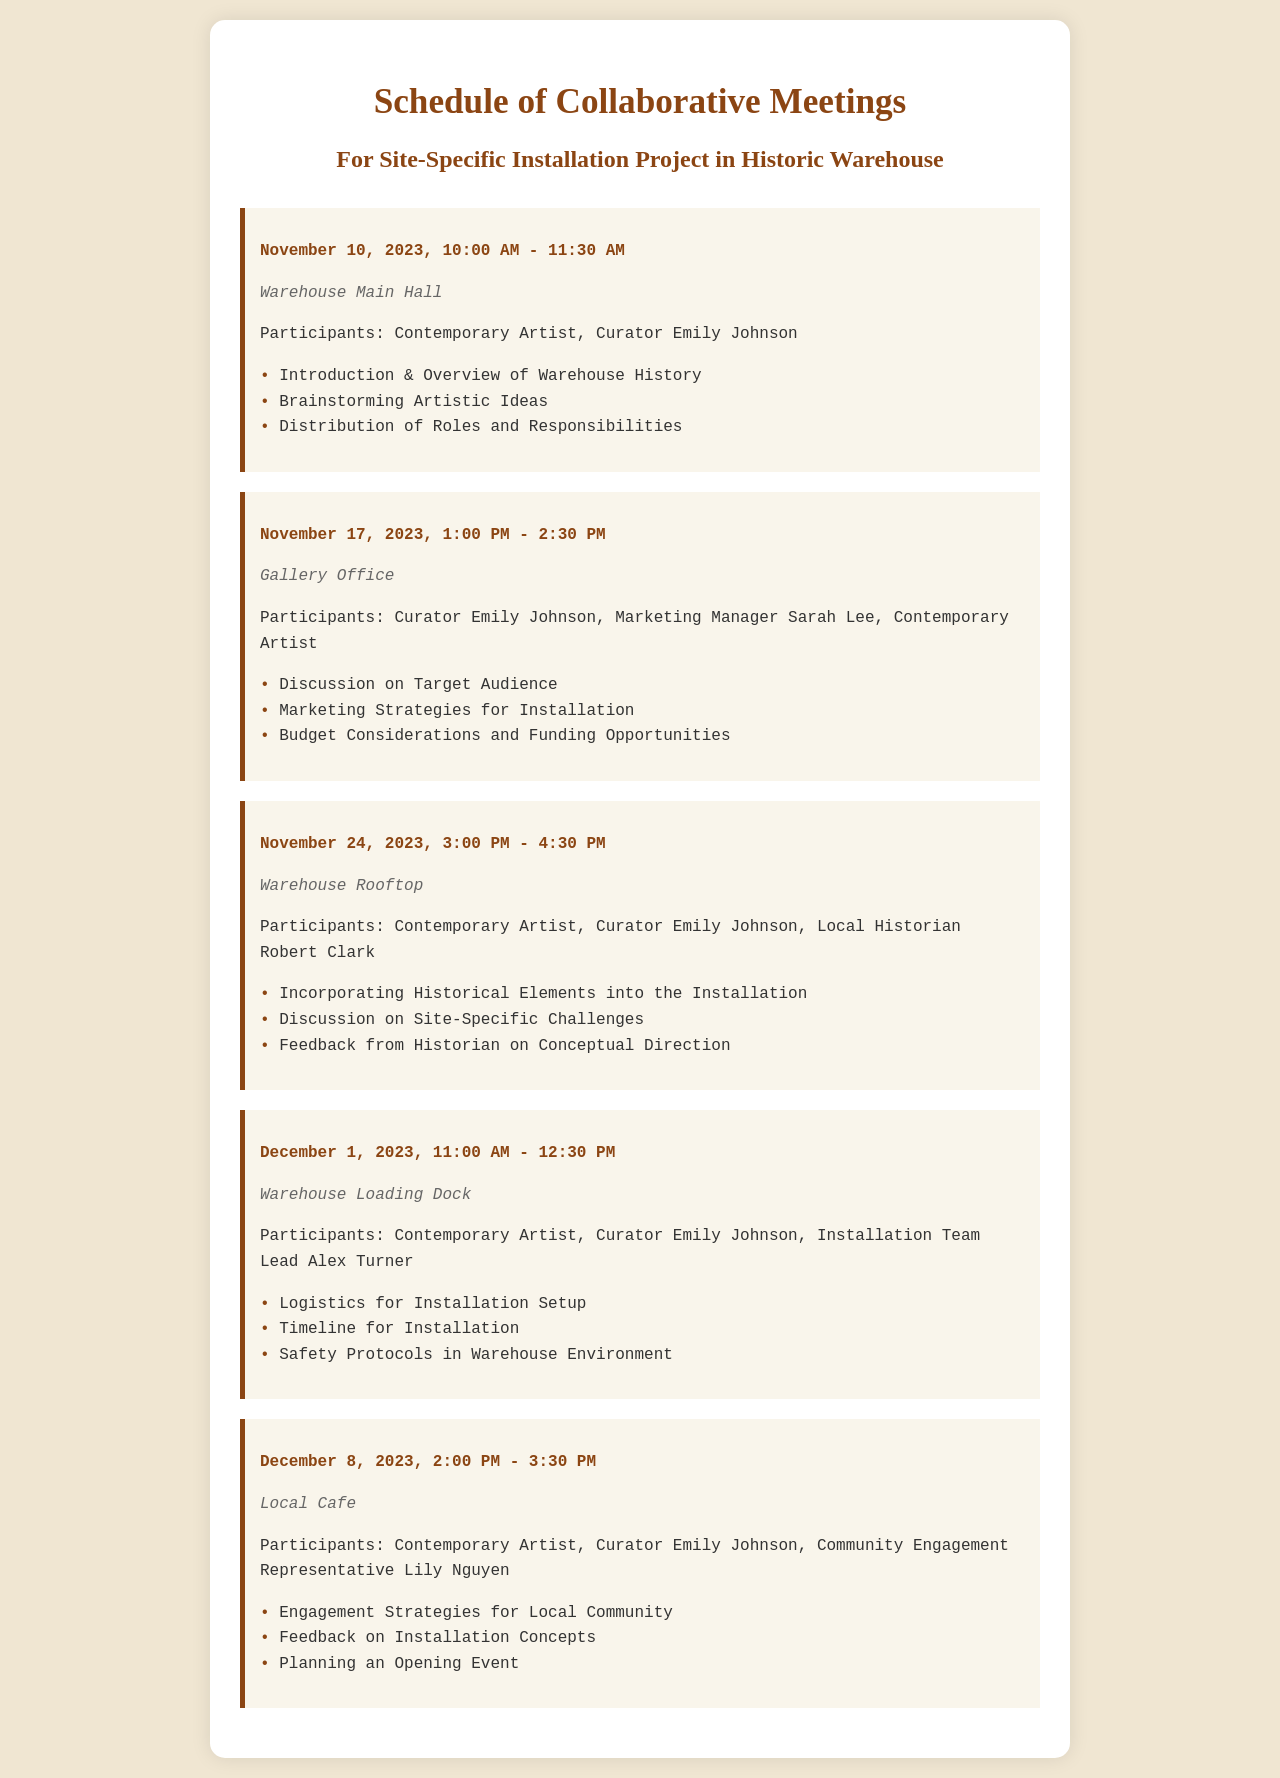What is the date and time of the first meeting? The first meeting is scheduled for November 10, 2023, at 10:00 AM.
Answer: November 10, 2023, 10:00 AM Who is participating in the second meeting? The second meeting involves the Curator, the Marketing Manager, and the Contemporary Artist.
Answer: Curator Emily Johnson, Marketing Manager Sarah Lee, Contemporary Artist Where is the fourth meeting held? The location of the fourth meeting is specified in the document.
Answer: Warehouse Loading Dock What is one agenda item for the meeting on November 24? The agenda for the November 24 meeting includes discussion on historical elements in the installation among others.
Answer: Incorporating Historical Elements into the Installation How long is the last meeting scheduled for? The duration of the last meeting can be calculated from the time it starts and ends, which is 1 hour and 30 minutes.
Answer: 1 hour and 30 minutes What is the main focus of the third meeting? The primary focus during the third meeting revolves around historical themes and site-specific challenges, reflecting a significant component of the project.
Answer: Incorporating Historical Elements into the Installation What type of meeting is scheduled for December 8? The meeting on December 8 is categorized as a community engagement session, which is essential for fostering local involvement.
Answer: Engagement Strategies for Local Community How many meetings are scheduled in total? The total count of meetings listed in the schedule provides a comprehensive overview for planning purposes.
Answer: Five meetings 